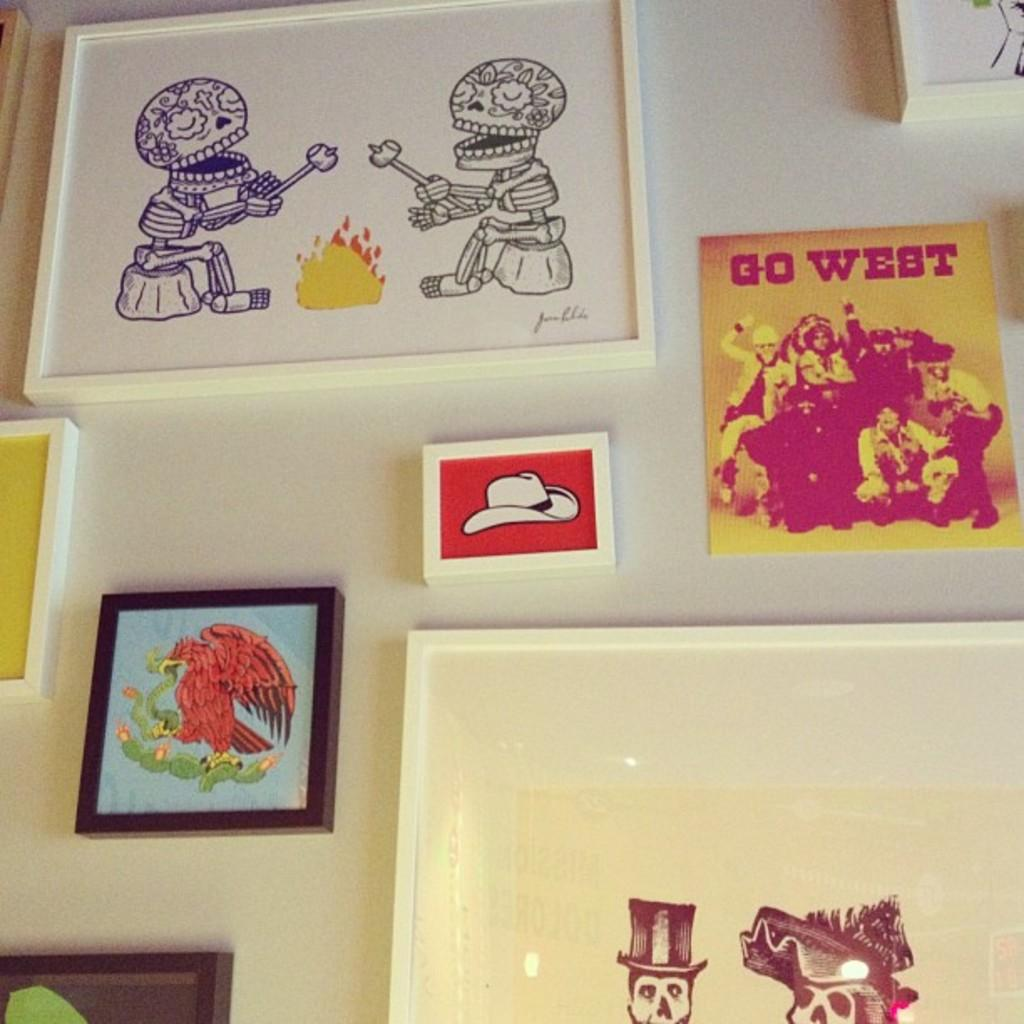<image>
Relay a brief, clear account of the picture shown. A number of works art are displayed including one titled GO WEST. 